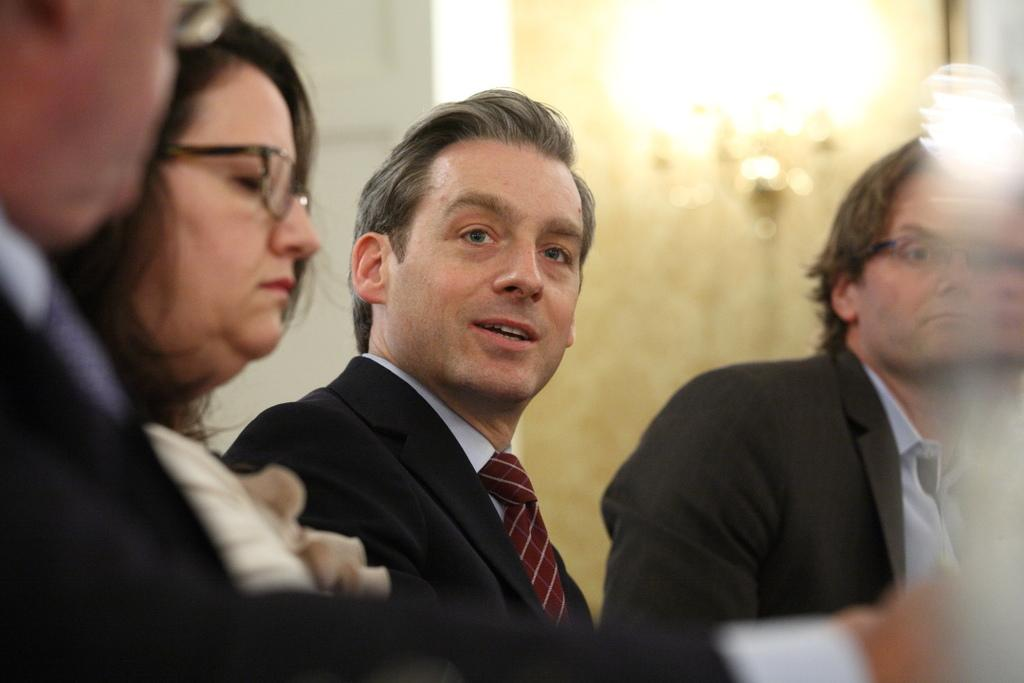Who or what is present in the image? There are people in the image. Can you describe the background of the image? The background of the image is blurred. How many trees are visible in the image? There is no tree present in the image; the background is blurred. 